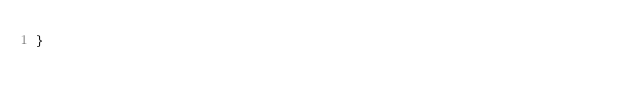Convert code to text. <code><loc_0><loc_0><loc_500><loc_500><_Java_>}
</code> 